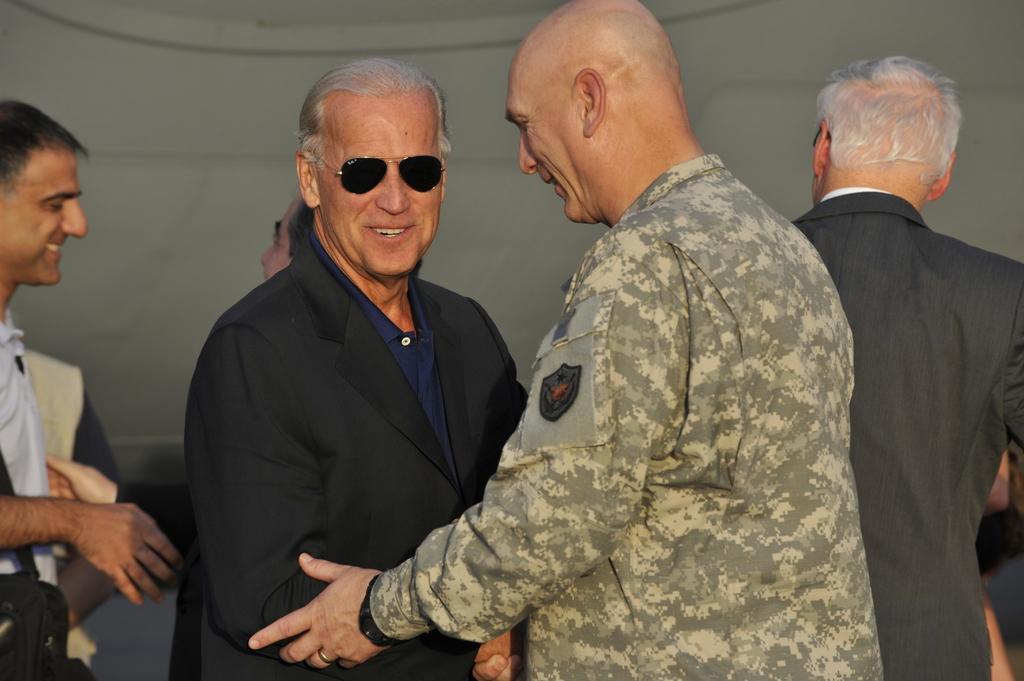Could you give a brief overview of what you see in this image? In this image I can see few people are standing and they are wearing different color dresses. Background is in grey color. 